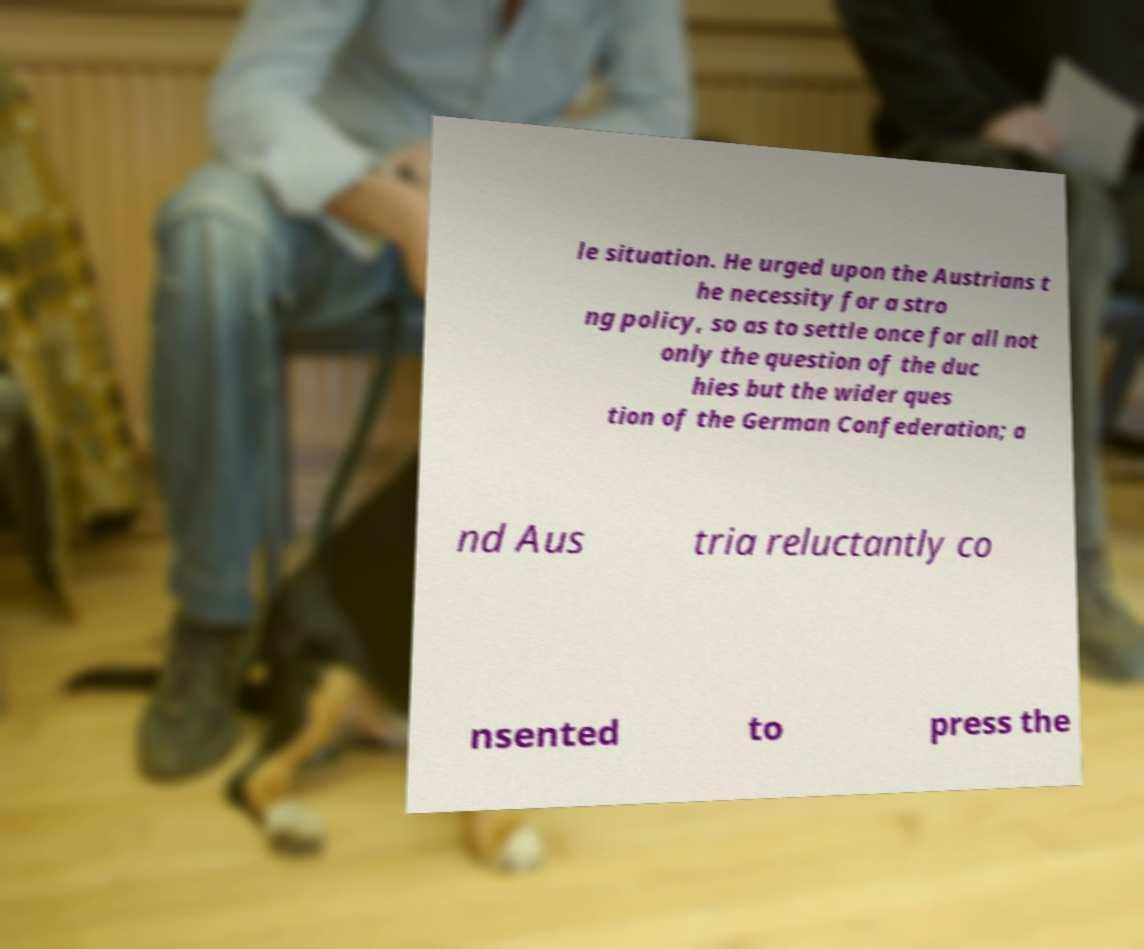Could you extract and type out the text from this image? le situation. He urged upon the Austrians t he necessity for a stro ng policy, so as to settle once for all not only the question of the duc hies but the wider ques tion of the German Confederation; a nd Aus tria reluctantly co nsented to press the 